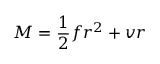<formula> <loc_0><loc_0><loc_500><loc_500>M = { \frac { 1 } { 2 } } f r ^ { 2 } + v r</formula> 